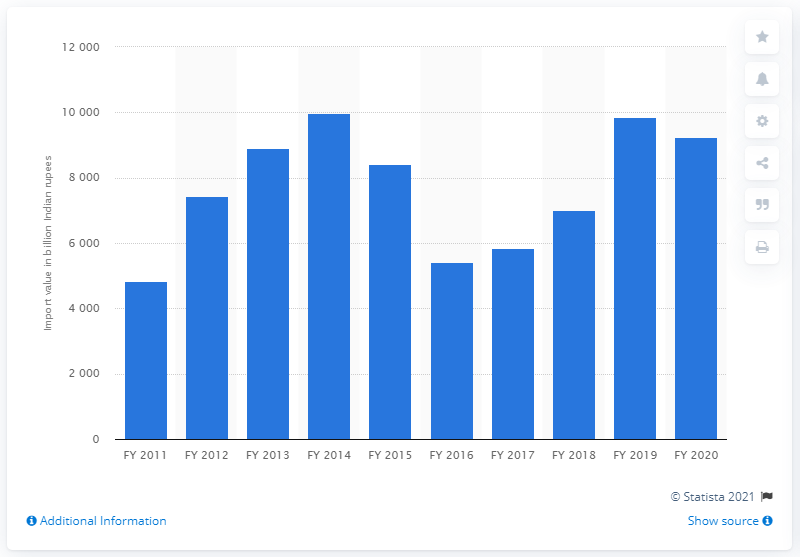List a handful of essential elements in this visual. In the fiscal year 2020, the import value of petroleum, crude and its products was approximately $98,627.50. 